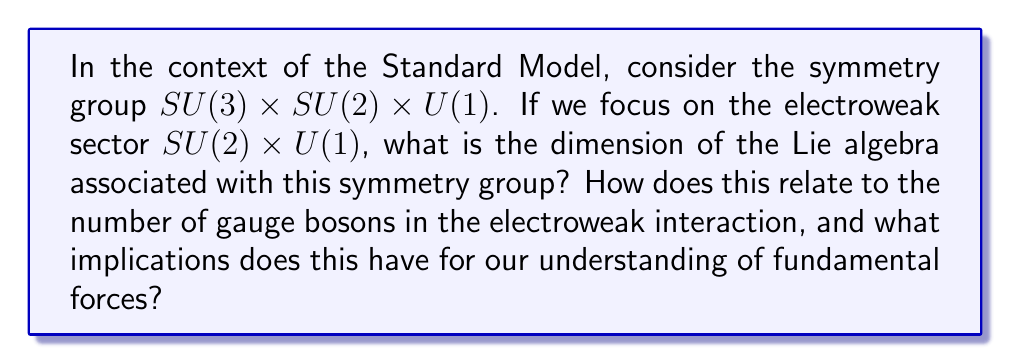Give your solution to this math problem. To approach this problem, we need to consider the structure of the symmetry group and its associated Lie algebra:

1) The electroweak sector is described by $SU(2) \times U(1)$:
   - $SU(2)$ is the special unitary group of degree 2
   - $U(1)$ is the unitary group of degree 1

2) The dimension of a Lie algebra is equal to the number of generators of the corresponding Lie group:
   - For $SU(n)$, the dimension is $n^2 - 1$
   - For $U(1)$, the dimension is 1

3) Calculate the dimensions:
   - $dim(SU(2)) = 2^2 - 1 = 3$
   - $dim(U(1)) = 1$

4) The total dimension is the sum of the individual dimensions:
   $dim(SU(2) \times U(1)) = dim(SU(2)) + dim(U(1)) = 3 + 1 = 4$

5) In quantum field theory, each generator of the symmetry group corresponds to a gauge boson:
   - The 3 generators of $SU(2)$ correspond to the $W^+$, $W^-$, and $Z^0$ bosons
   - The 1 generator of $U(1)$ corresponds to the photon

6) Implications for our understanding of fundamental forces:
   - The dimension of the Lie algebra directly relates to the number of force carriers
   - This mathematical structure underpins the unification of electromagnetic and weak forces
   - It demonstrates how abstract mathematical concepts (symmetry groups) can predict physical phenomena (gauge bosons)
   - The success of this model in electroweak theory has motivated searches for higher symmetries to unify all fundamental forces

This connection between abstract mathematics and physical reality highlights both the power and limitations of our scientific understanding. While the mathematical framework accurately predicts observable particles, it does not explain why nature chooses these particular symmetries or how they might break down at higher energy scales.
Answer: The dimension of the Lie algebra associated with the electroweak symmetry group $SU(2) \times U(1)$ is 4. This corresponds to the four gauge bosons of the electroweak interaction: $W^+$, $W^-$, $Z^0$, and the photon. 